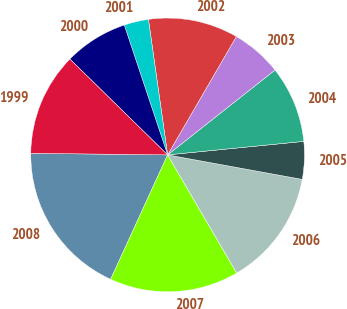<chart> <loc_0><loc_0><loc_500><loc_500><pie_chart><fcel>2008<fcel>2007<fcel>2006<fcel>2005<fcel>2004<fcel>2003<fcel>2002<fcel>2001<fcel>2000<fcel>1999<nl><fcel>18.35%<fcel>15.26%<fcel>13.71%<fcel>4.44%<fcel>9.07%<fcel>5.98%<fcel>10.62%<fcel>2.89%<fcel>7.53%<fcel>12.16%<nl></chart> 